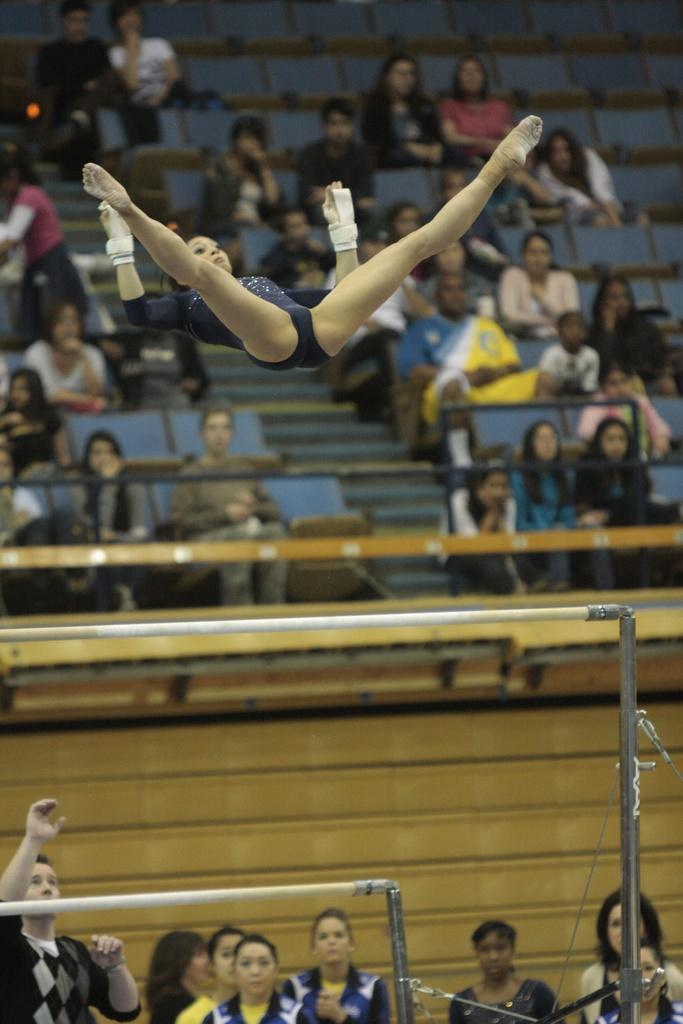Who is present in the image? There is a woman in the image, along with other people. What objects can be seen in the image? There are rods in the image. What is happening in the background of the image? In the background, there are more people sitting on chairs. What type of grape is being traded between the people in the image? There is no grape or trade activity present in the image. Can you point out the spot where the woman is standing in the image? The image does not have a specific spot marked for the woman's location; she is simply standing among the other people. 